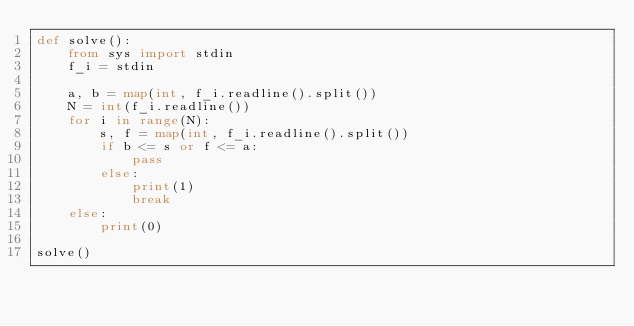Convert code to text. <code><loc_0><loc_0><loc_500><loc_500><_Python_>def solve():
    from sys import stdin
    f_i = stdin
    
    a, b = map(int, f_i.readline().split())
    N = int(f_i.readline())
    for i in range(N):
        s, f = map(int, f_i.readline().split())
        if b <= s or f <= a:
            pass
        else:
            print(1)
            break
    else:
        print(0)

solve()
</code> 